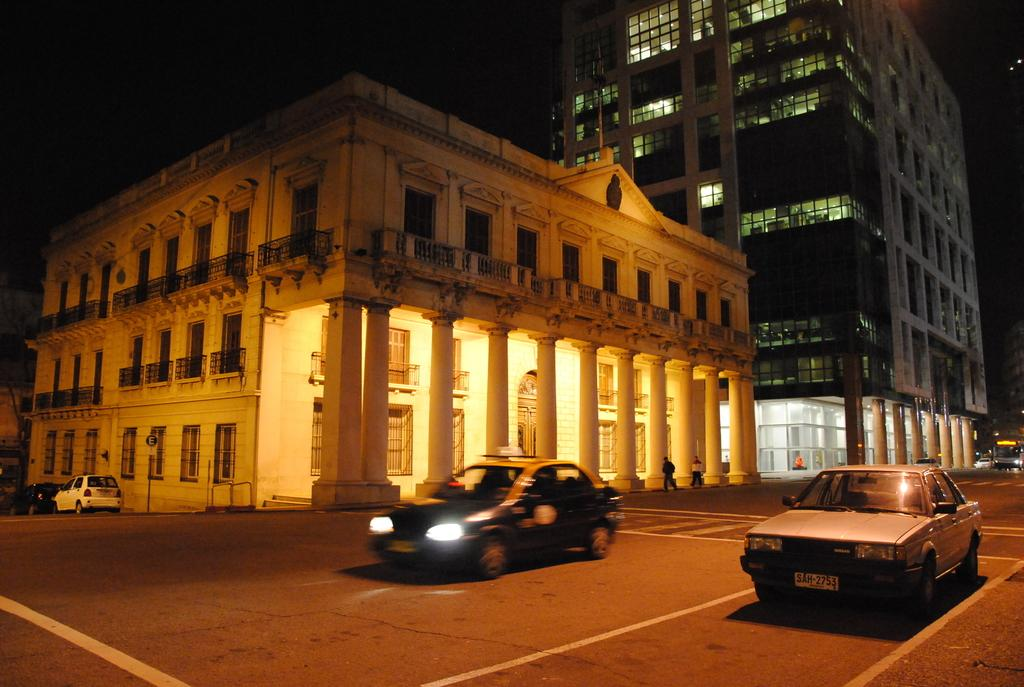What is located in the front of the image? There are cars in the front of the image. What can be seen in the background of the image? There are buildings and persons in the background of the image. Are there any other vehicles visible in the image? Yes, there are vehicles in the background of the image. What type of print can be seen on the stage in the image? There is no stage or print present in the image. How many quince are visible on the vehicles in the image? There are no quince present in the image. 